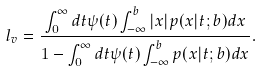Convert formula to latex. <formula><loc_0><loc_0><loc_500><loc_500>l _ { v } = \frac { \int _ { 0 } ^ { \infty } d t \psi ( t ) \int _ { - \infty } ^ { b } | x | p ( x | t ; b ) d x } { 1 - \int _ { 0 } ^ { \infty } d t \psi ( t ) \int _ { - \infty } ^ { b } p ( x | t ; b ) d x } .</formula> 